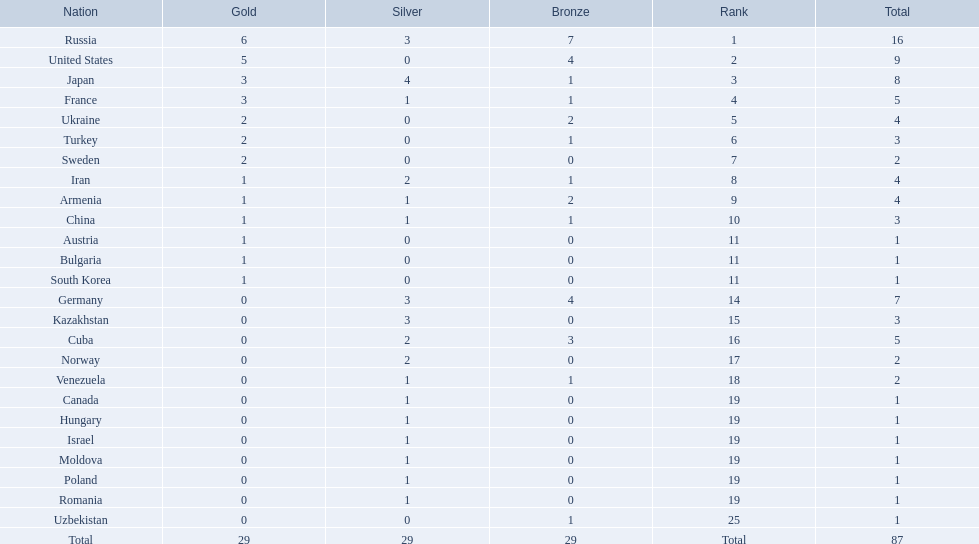Which nations participated in the championships? Russia, United States, Japan, France, Ukraine, Turkey, Sweden, Iran, Armenia, China, Austria, Bulgaria, South Korea, Germany, Kazakhstan, Cuba, Norway, Venezuela, Canada, Hungary, Israel, Moldova, Poland, Romania, Uzbekistan. How many bronze medals did they receive? 7, 4, 1, 1, 2, 1, 0, 1, 2, 1, 0, 0, 0, 4, 0, 3, 0, 1, 0, 0, 0, 0, 0, 0, 1, 29. How many in total? 16, 9, 8, 5, 4, 3, 2, 4, 4, 3, 1, 1, 1, 7, 3, 5, 2, 2, 1, 1, 1, 1, 1, 1, 1. And which team won only one medal -- the bronze? Uzbekistan. 